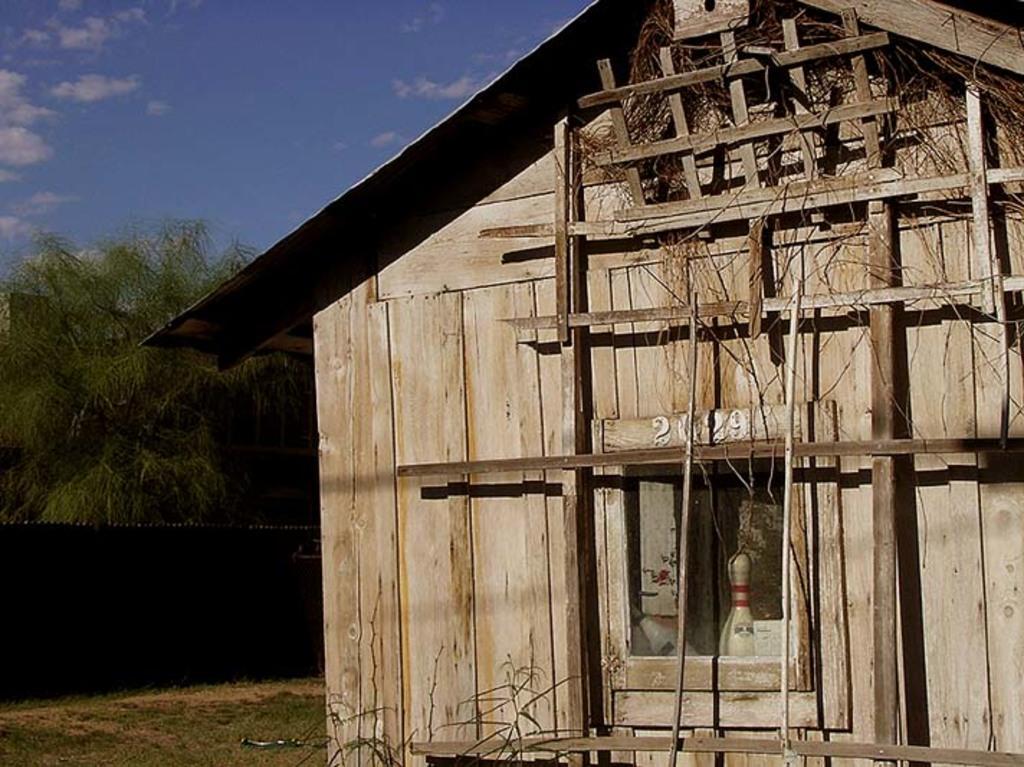How would you summarize this image in a sentence or two? In the picture I can see a wooden house, trees, fence and some other objects. In the background I can see the sky. 